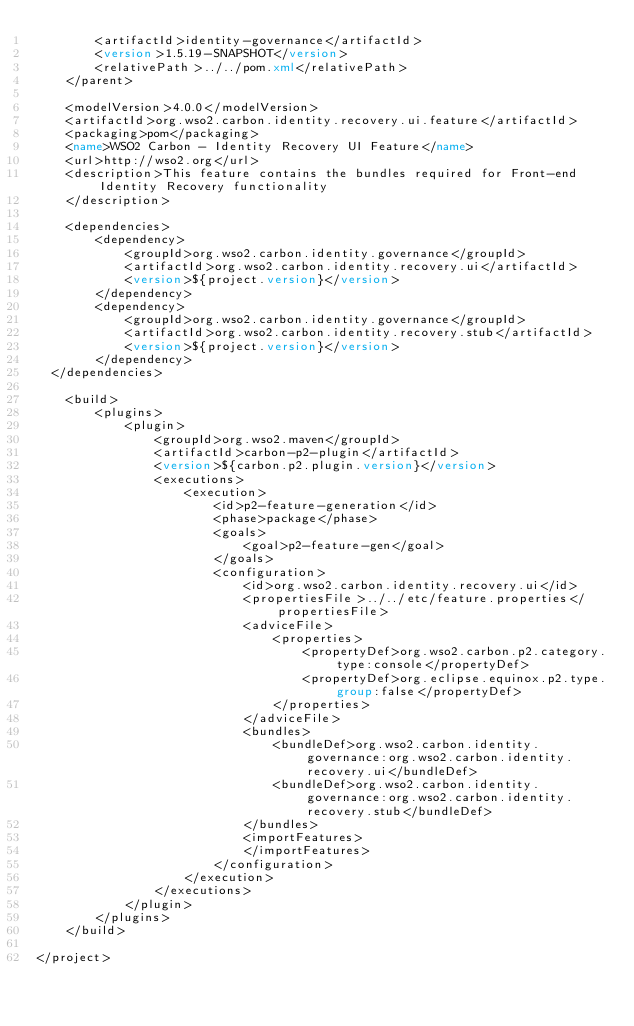Convert code to text. <code><loc_0><loc_0><loc_500><loc_500><_XML_>        <artifactId>identity-governance</artifactId>
        <version>1.5.19-SNAPSHOT</version>
        <relativePath>../../pom.xml</relativePath>
    </parent>

    <modelVersion>4.0.0</modelVersion>
    <artifactId>org.wso2.carbon.identity.recovery.ui.feature</artifactId>
    <packaging>pom</packaging>
    <name>WSO2 Carbon - Identity Recovery UI Feature</name>
    <url>http://wso2.org</url>
    <description>This feature contains the bundles required for Front-end Identity Recovery functionality
    </description>

    <dependencies>
        <dependency>
            <groupId>org.wso2.carbon.identity.governance</groupId>
            <artifactId>org.wso2.carbon.identity.recovery.ui</artifactId>
            <version>${project.version}</version>
        </dependency>
        <dependency>
            <groupId>org.wso2.carbon.identity.governance</groupId>
            <artifactId>org.wso2.carbon.identity.recovery.stub</artifactId>
            <version>${project.version}</version>
        </dependency>
	</dependencies>

    <build>
        <plugins>
            <plugin>
                <groupId>org.wso2.maven</groupId>
                <artifactId>carbon-p2-plugin</artifactId>
                <version>${carbon.p2.plugin.version}</version>
                <executions>
                    <execution>
                        <id>p2-feature-generation</id>
                        <phase>package</phase>
                        <goals>
                            <goal>p2-feature-gen</goal>
                        </goals>
                        <configuration>
                            <id>org.wso2.carbon.identity.recovery.ui</id>
                            <propertiesFile>../../etc/feature.properties</propertiesFile>
                            <adviceFile>
                                <properties>
                                    <propertyDef>org.wso2.carbon.p2.category.type:console</propertyDef>
                                    <propertyDef>org.eclipse.equinox.p2.type.group:false</propertyDef>
                                </properties>
                            </adviceFile>
                            <bundles>
                                <bundleDef>org.wso2.carbon.identity.governance:org.wso2.carbon.identity.recovery.ui</bundleDef>
                                <bundleDef>org.wso2.carbon.identity.governance:org.wso2.carbon.identity.recovery.stub</bundleDef>
                            </bundles>
                            <importFeatures>
                            </importFeatures>
                        </configuration>
                    </execution>
                </executions>
            </plugin>
        </plugins>
    </build>

</project>
</code> 